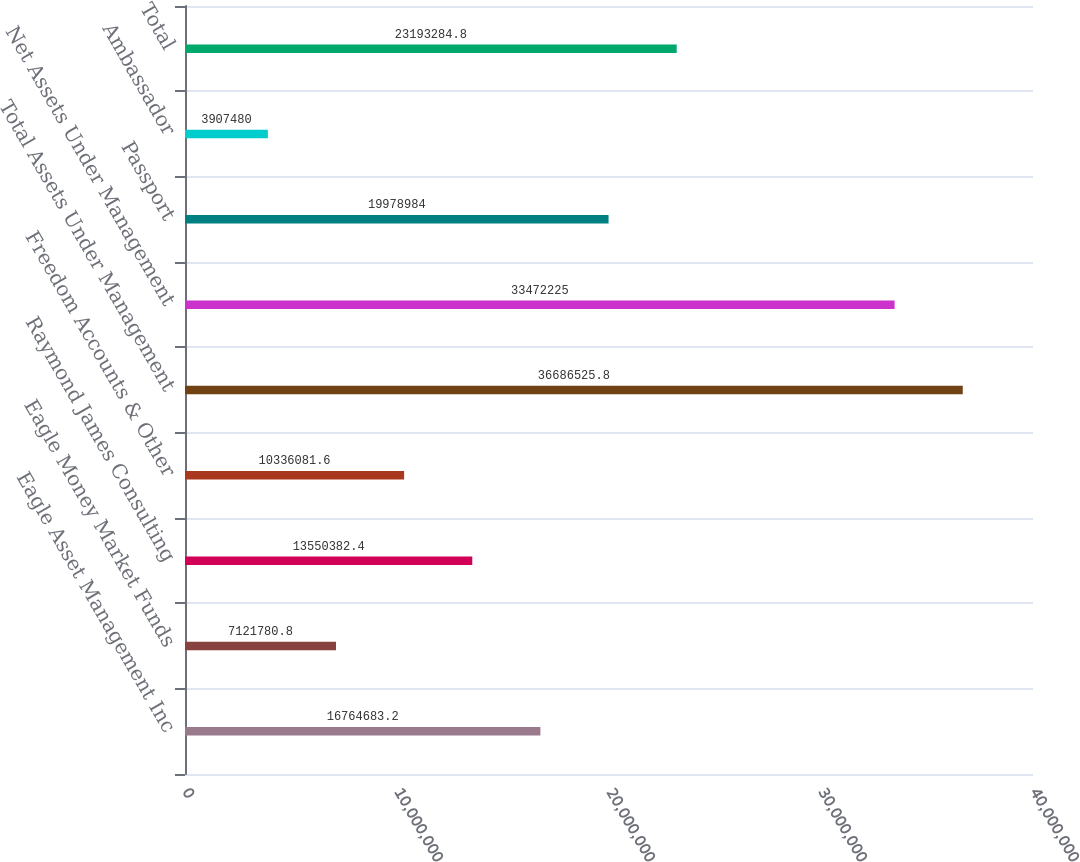<chart> <loc_0><loc_0><loc_500><loc_500><bar_chart><fcel>Eagle Asset Management Inc<fcel>Eagle Money Market Funds<fcel>Raymond James Consulting<fcel>Freedom Accounts & Other<fcel>Total Assets Under Management<fcel>Net Assets Under Management<fcel>Passport<fcel>Ambassador<fcel>Total<nl><fcel>1.67647e+07<fcel>7.12178e+06<fcel>1.35504e+07<fcel>1.03361e+07<fcel>3.66865e+07<fcel>3.34722e+07<fcel>1.9979e+07<fcel>3.90748e+06<fcel>2.31933e+07<nl></chart> 